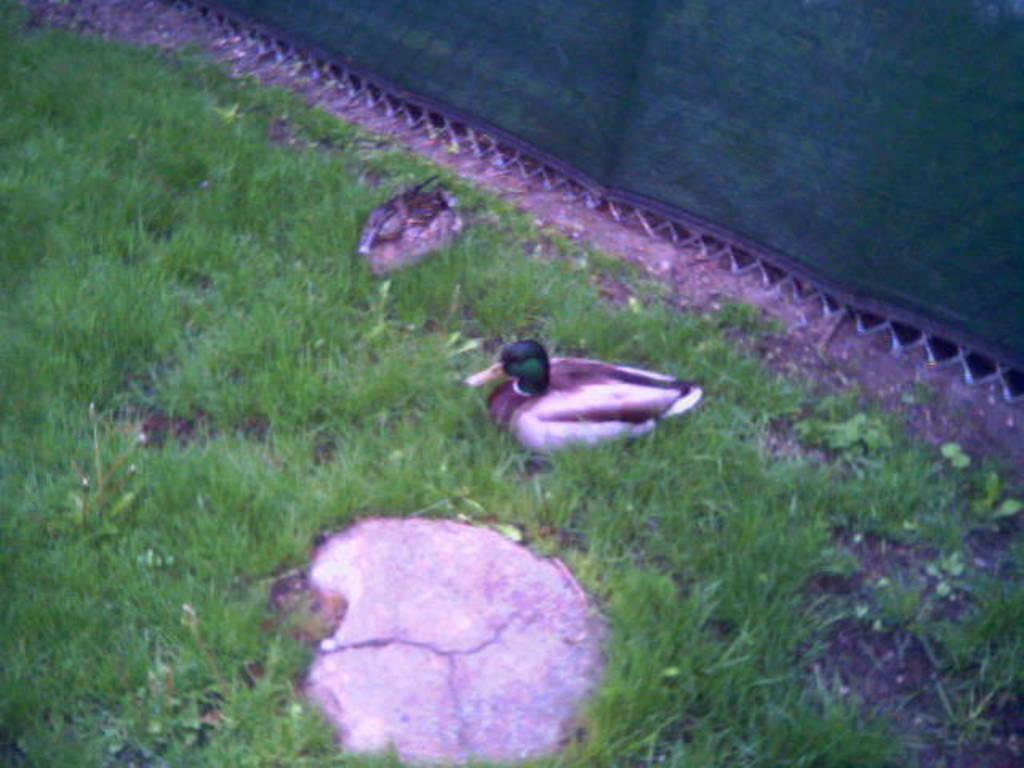Could you give a brief overview of what you see in this image? This picture is clicked outside and we can see the birds, green grass and some other objects. 